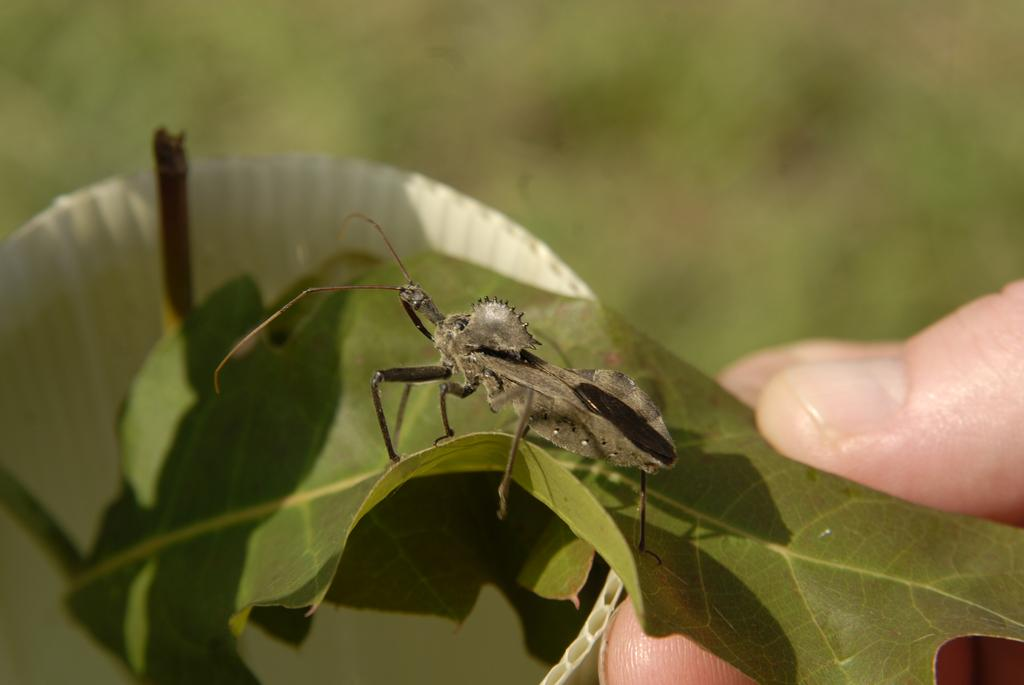What is the main subject of the image? The main subject of the image is an insect on a leaf. What else can be seen in the image besides the insect? Human fingers are visible on the right side of the image, and there is a white color object in the image. How would you describe the background of the image? The background has a blurred view. How does the zebra contribute to the profit of the company in the image? There is no zebra or company mentioned in the image; it features an insect on a leaf and human fingers. 